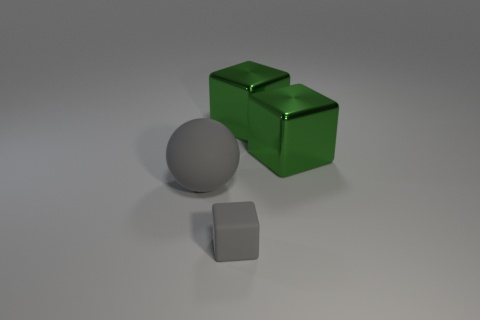Add 1 green metallic things. How many objects exist? 5 Subtract all cubes. How many objects are left? 1 Add 3 big objects. How many big objects exist? 6 Subtract 0 cyan cubes. How many objects are left? 4 Subtract all balls. Subtract all small green rubber blocks. How many objects are left? 3 Add 3 gray matte balls. How many gray matte balls are left? 4 